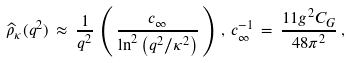Convert formula to latex. <formula><loc_0><loc_0><loc_500><loc_500>\widehat { \rho } _ { \kappa } ( q ^ { 2 } ) \, \approx \, \frac { 1 } { q ^ { 2 } } \, \left ( \, \frac { c _ { \infty } } { \ln ^ { 2 } \left ( q ^ { 2 } / \kappa ^ { 2 } \right ) } \, \right ) \, , \, c _ { \infty } ^ { - 1 } \, = \, \frac { 1 1 g ^ { 2 } C _ { G } } { 4 8 \pi ^ { 2 } } \, ,</formula> 